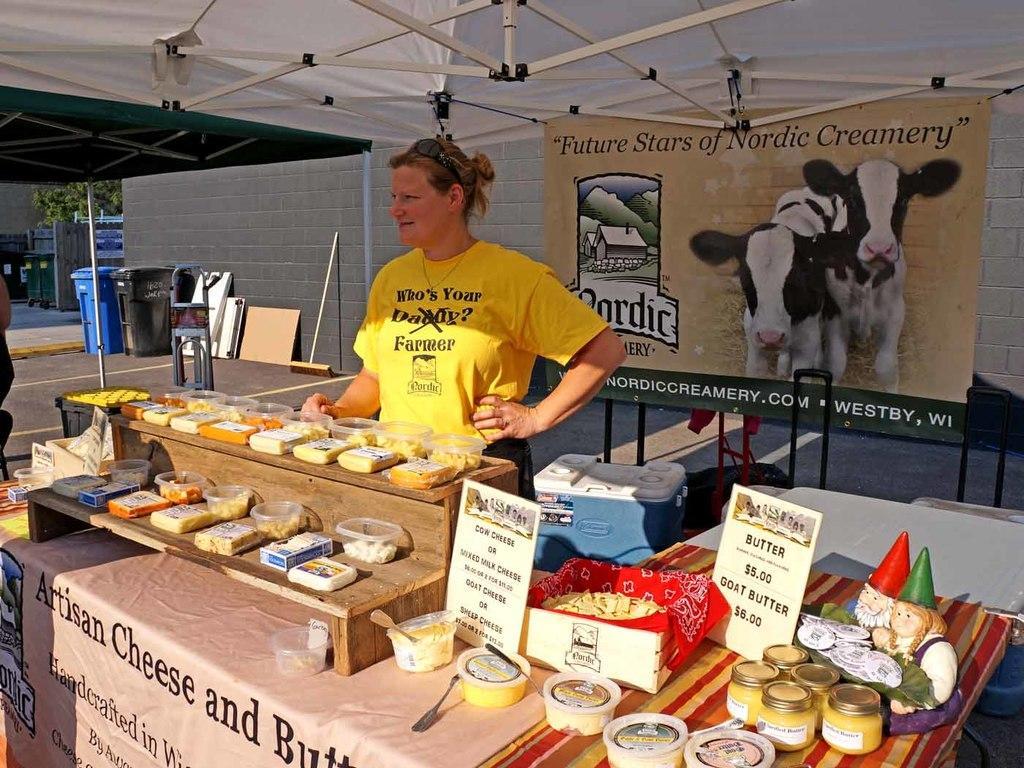In one or two sentences, can you explain what this image depicts? In this picture we can observe a stall. We can observe some food items placed on the wooden desk which is on the table. There is a woman standing, wearing yellow color T shirt. In the background we can observe a board. She is standing under the white color tint. We can observe white color wall and two trash bins in the background. 